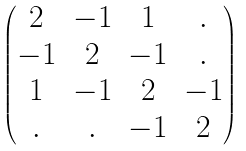<formula> <loc_0><loc_0><loc_500><loc_500>\begin{pmatrix} 2 & - 1 & 1 & . \\ - 1 & 2 & - 1 & . \\ 1 & - 1 & 2 & - 1 \\ . & . & - 1 & 2 \end{pmatrix}</formula> 